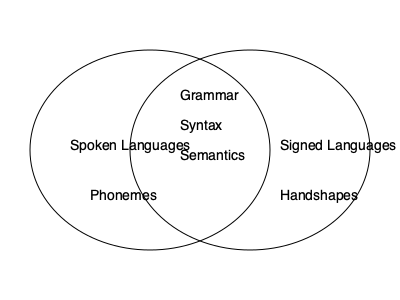Based on the Venn diagram, which linguistic features are shared between spoken and signed languages? To answer this question, we need to analyze the Venn diagram step-by-step:

1. The diagram shows two overlapping circles, representing spoken languages and signed languages.

2. The overlapping area contains linguistic features that are common to both spoken and signed languages.

3. In this overlapping area, we can see three linguistic features listed:
   a) Grammar
   b) Syntax
   c) Semantics

4. Outside the overlapping area, we see:
   - "Phonemes" in the spoken languages circle
   - "Handshapes" in the signed languages circle

5. These non-overlapping features are specific to each language type and not shared between them.

Therefore, the linguistic features shared between spoken and signed languages, as shown in the overlapping area of the Venn diagram, are grammar, syntax, and semantics.
Answer: Grammar, syntax, and semantics 